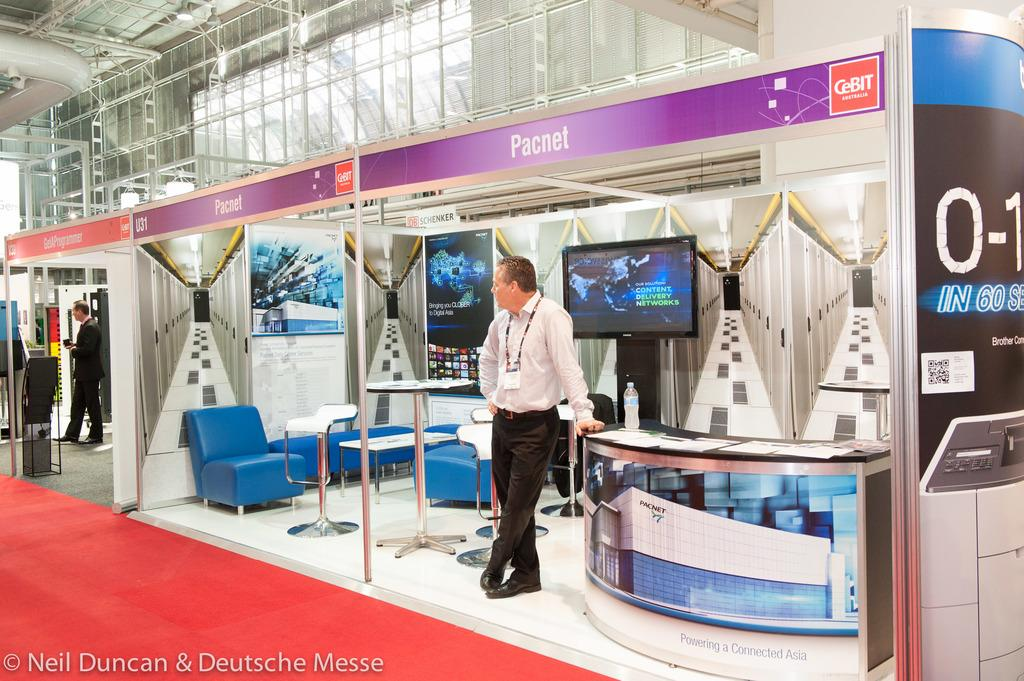What is the person in the image doing? The person is standing beside a table. What can be seen on the table in the image? There is a bottle on the table, along with other objects. What electronic device is present in the image? There is a TV in the image. What else can be seen on the ground in the image? There are other objects on the ground. Can you see a girl playing in the ocean in the image? No, there is no girl playing in the ocean in the image. 